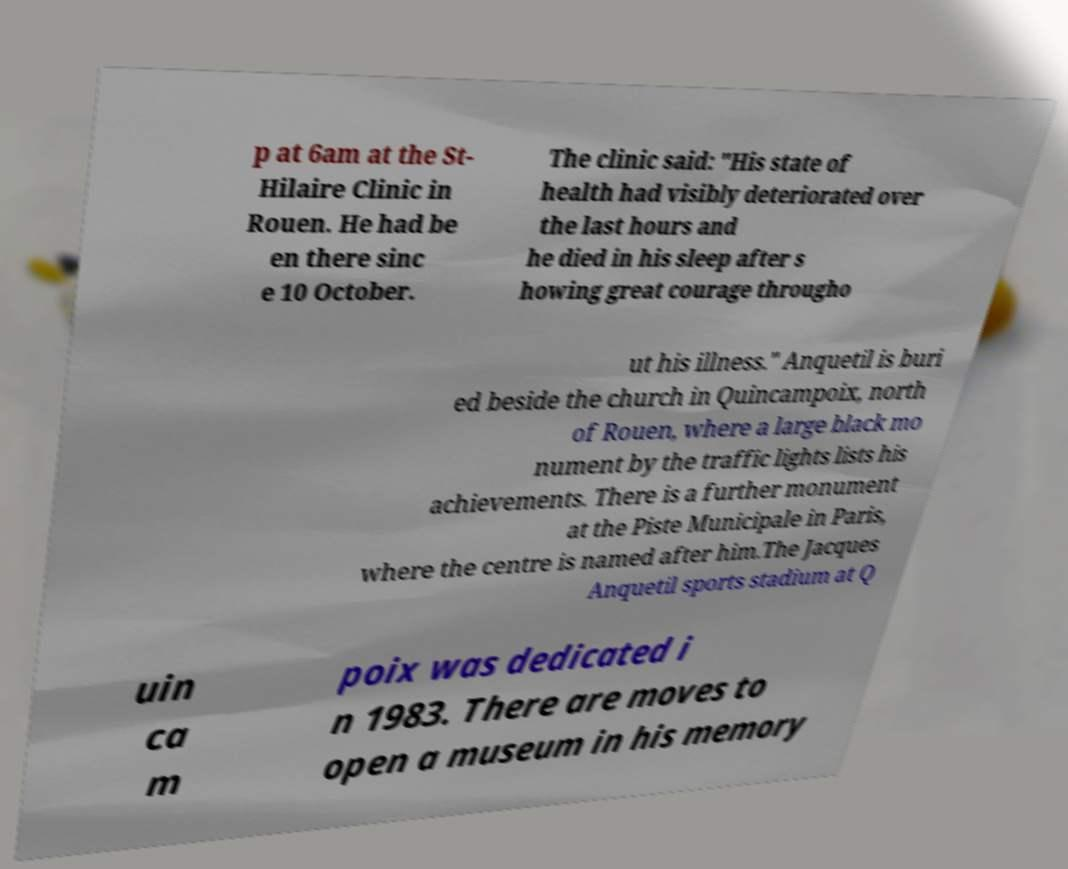Please read and relay the text visible in this image. What does it say? p at 6am at the St- Hilaire Clinic in Rouen. He had be en there sinc e 10 October. The clinic said: "His state of health had visibly deteriorated over the last hours and he died in his sleep after s howing great courage througho ut his illness." Anquetil is buri ed beside the church in Quincampoix, north of Rouen, where a large black mo nument by the traffic lights lists his achievements. There is a further monument at the Piste Municipale in Paris, where the centre is named after him.The Jacques Anquetil sports stadium at Q uin ca m poix was dedicated i n 1983. There are moves to open a museum in his memory 